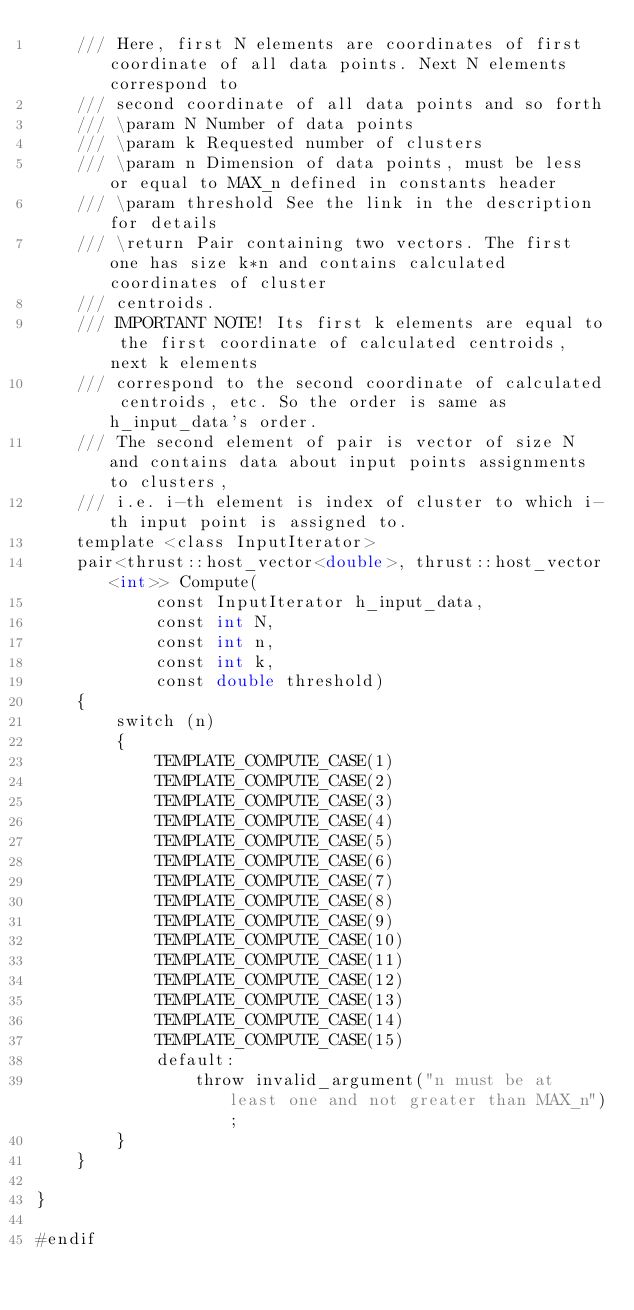<code> <loc_0><loc_0><loc_500><loc_500><_Cuda_>    /// Here, first N elements are coordinates of first coordinate of all data points. Next N elements correspond to
    /// second coordinate of all data points and so forth
    /// \param N Number of data points
    /// \param k Requested number of clusters
    /// \param n Dimension of data points, must be less or equal to MAX_n defined in constants header
    /// \param threshold See the link in the description for details
    /// \return Pair containing two vectors. The first one has size k*n and contains calculated coordinates of cluster
    /// centroids.
    /// IMPORTANT NOTE! Its first k elements are equal to the first coordinate of calculated centroids, next k elements
    /// correspond to the second coordinate of calculated centroids, etc. So the order is same as h_input_data's order.
    /// The second element of pair is vector of size N and contains data about input points assignments to clusters,
    /// i.e. i-th element is index of cluster to which i-th input point is assigned to.
    template <class InputIterator>
    pair<thrust::host_vector<double>, thrust::host_vector<int>> Compute(
            const InputIterator h_input_data,
            const int N,
            const int n,
            const int k,
            const double threshold)
    {
        switch (n)
        {
            TEMPLATE_COMPUTE_CASE(1)
            TEMPLATE_COMPUTE_CASE(2)
            TEMPLATE_COMPUTE_CASE(3)
            TEMPLATE_COMPUTE_CASE(4)
            TEMPLATE_COMPUTE_CASE(5)
            TEMPLATE_COMPUTE_CASE(6)
            TEMPLATE_COMPUTE_CASE(7)
            TEMPLATE_COMPUTE_CASE(8)
            TEMPLATE_COMPUTE_CASE(9)
            TEMPLATE_COMPUTE_CASE(10)
            TEMPLATE_COMPUTE_CASE(11)
            TEMPLATE_COMPUTE_CASE(12)
            TEMPLATE_COMPUTE_CASE(13)
            TEMPLATE_COMPUTE_CASE(14)
            TEMPLATE_COMPUTE_CASE(15)
            default:
                throw invalid_argument("n must be at least one and not greater than MAX_n");
        }
    }

}

#endif</code> 